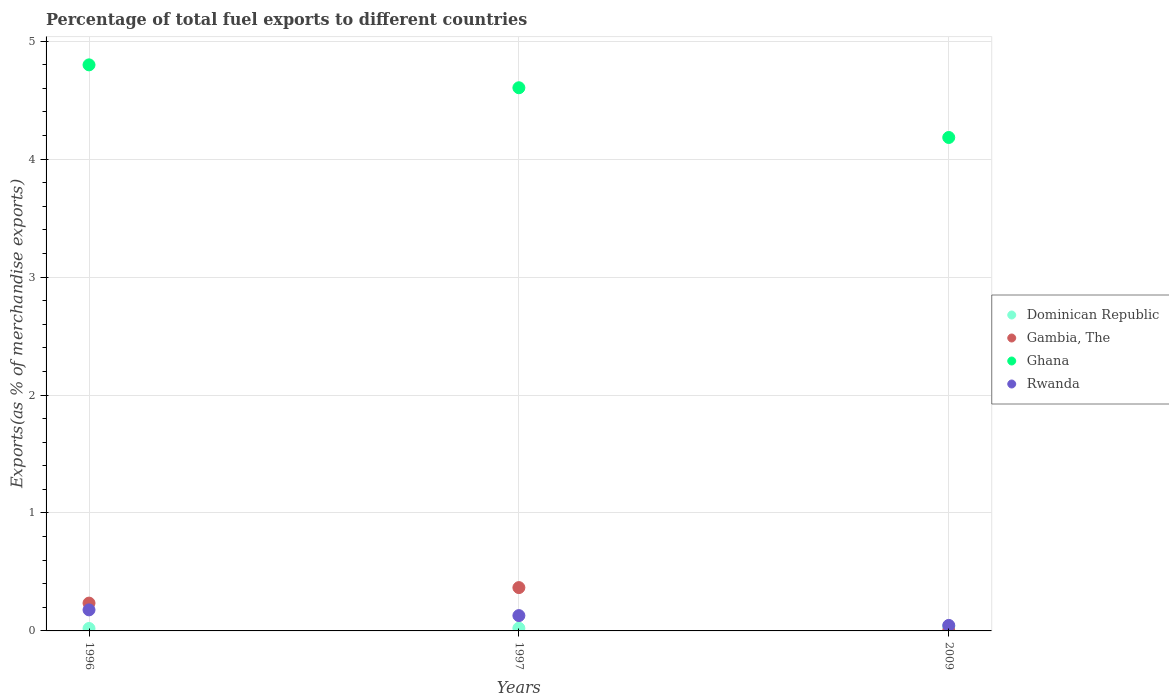How many different coloured dotlines are there?
Provide a short and direct response. 4. What is the percentage of exports to different countries in Gambia, The in 2009?
Your answer should be very brief. 0. Across all years, what is the maximum percentage of exports to different countries in Ghana?
Give a very brief answer. 4.8. Across all years, what is the minimum percentage of exports to different countries in Ghana?
Your answer should be very brief. 4.18. In which year was the percentage of exports to different countries in Ghana minimum?
Offer a terse response. 2009. What is the total percentage of exports to different countries in Dominican Republic in the graph?
Ensure brevity in your answer.  0.08. What is the difference between the percentage of exports to different countries in Ghana in 1997 and that in 2009?
Make the answer very short. 0.42. What is the difference between the percentage of exports to different countries in Rwanda in 1997 and the percentage of exports to different countries in Dominican Republic in 2009?
Your answer should be very brief. 0.09. What is the average percentage of exports to different countries in Rwanda per year?
Your response must be concise. 0.12. In the year 1997, what is the difference between the percentage of exports to different countries in Ghana and percentage of exports to different countries in Dominican Republic?
Your answer should be very brief. 4.58. What is the ratio of the percentage of exports to different countries in Ghana in 1996 to that in 2009?
Provide a succinct answer. 1.15. Is the difference between the percentage of exports to different countries in Ghana in 1997 and 2009 greater than the difference between the percentage of exports to different countries in Dominican Republic in 1997 and 2009?
Your answer should be compact. Yes. What is the difference between the highest and the second highest percentage of exports to different countries in Dominican Republic?
Provide a succinct answer. 0.02. What is the difference between the highest and the lowest percentage of exports to different countries in Ghana?
Your response must be concise. 0.62. Does the percentage of exports to different countries in Gambia, The monotonically increase over the years?
Provide a short and direct response. No. Is the percentage of exports to different countries in Gambia, The strictly less than the percentage of exports to different countries in Ghana over the years?
Ensure brevity in your answer.  Yes. How many years are there in the graph?
Offer a terse response. 3. Are the values on the major ticks of Y-axis written in scientific E-notation?
Your response must be concise. No. Does the graph contain grids?
Ensure brevity in your answer.  Yes. What is the title of the graph?
Provide a short and direct response. Percentage of total fuel exports to different countries. What is the label or title of the X-axis?
Keep it short and to the point. Years. What is the label or title of the Y-axis?
Your answer should be compact. Exports(as % of merchandise exports). What is the Exports(as % of merchandise exports) of Dominican Republic in 1996?
Your response must be concise. 0.02. What is the Exports(as % of merchandise exports) in Gambia, The in 1996?
Your answer should be very brief. 0.24. What is the Exports(as % of merchandise exports) in Ghana in 1996?
Provide a succinct answer. 4.8. What is the Exports(as % of merchandise exports) in Rwanda in 1996?
Keep it short and to the point. 0.18. What is the Exports(as % of merchandise exports) in Dominican Republic in 1997?
Ensure brevity in your answer.  0.02. What is the Exports(as % of merchandise exports) in Gambia, The in 1997?
Make the answer very short. 0.37. What is the Exports(as % of merchandise exports) of Ghana in 1997?
Offer a terse response. 4.6. What is the Exports(as % of merchandise exports) of Rwanda in 1997?
Ensure brevity in your answer.  0.13. What is the Exports(as % of merchandise exports) in Dominican Republic in 2009?
Offer a very short reply. 0.04. What is the Exports(as % of merchandise exports) of Gambia, The in 2009?
Make the answer very short. 0. What is the Exports(as % of merchandise exports) in Ghana in 2009?
Provide a succinct answer. 4.18. What is the Exports(as % of merchandise exports) of Rwanda in 2009?
Provide a short and direct response. 0.05. Across all years, what is the maximum Exports(as % of merchandise exports) in Dominican Republic?
Your answer should be compact. 0.04. Across all years, what is the maximum Exports(as % of merchandise exports) in Gambia, The?
Offer a terse response. 0.37. Across all years, what is the maximum Exports(as % of merchandise exports) of Ghana?
Keep it short and to the point. 4.8. Across all years, what is the maximum Exports(as % of merchandise exports) in Rwanda?
Your answer should be very brief. 0.18. Across all years, what is the minimum Exports(as % of merchandise exports) of Dominican Republic?
Offer a terse response. 0.02. Across all years, what is the minimum Exports(as % of merchandise exports) in Gambia, The?
Give a very brief answer. 0. Across all years, what is the minimum Exports(as % of merchandise exports) of Ghana?
Your answer should be very brief. 4.18. Across all years, what is the minimum Exports(as % of merchandise exports) of Rwanda?
Keep it short and to the point. 0.05. What is the total Exports(as % of merchandise exports) of Dominican Republic in the graph?
Give a very brief answer. 0.08. What is the total Exports(as % of merchandise exports) in Gambia, The in the graph?
Ensure brevity in your answer.  0.61. What is the total Exports(as % of merchandise exports) of Ghana in the graph?
Keep it short and to the point. 13.59. What is the total Exports(as % of merchandise exports) of Rwanda in the graph?
Ensure brevity in your answer.  0.35. What is the difference between the Exports(as % of merchandise exports) in Dominican Republic in 1996 and that in 1997?
Your answer should be compact. -0. What is the difference between the Exports(as % of merchandise exports) in Gambia, The in 1996 and that in 1997?
Provide a succinct answer. -0.13. What is the difference between the Exports(as % of merchandise exports) of Ghana in 1996 and that in 1997?
Make the answer very short. 0.19. What is the difference between the Exports(as % of merchandise exports) of Rwanda in 1996 and that in 1997?
Provide a succinct answer. 0.05. What is the difference between the Exports(as % of merchandise exports) of Dominican Republic in 1996 and that in 2009?
Provide a short and direct response. -0.02. What is the difference between the Exports(as % of merchandise exports) of Gambia, The in 1996 and that in 2009?
Your response must be concise. 0.23. What is the difference between the Exports(as % of merchandise exports) of Ghana in 1996 and that in 2009?
Your response must be concise. 0.62. What is the difference between the Exports(as % of merchandise exports) in Rwanda in 1996 and that in 2009?
Ensure brevity in your answer.  0.13. What is the difference between the Exports(as % of merchandise exports) in Dominican Republic in 1997 and that in 2009?
Keep it short and to the point. -0.02. What is the difference between the Exports(as % of merchandise exports) of Gambia, The in 1997 and that in 2009?
Your answer should be compact. 0.36. What is the difference between the Exports(as % of merchandise exports) in Ghana in 1997 and that in 2009?
Provide a succinct answer. 0.42. What is the difference between the Exports(as % of merchandise exports) in Rwanda in 1997 and that in 2009?
Ensure brevity in your answer.  0.08. What is the difference between the Exports(as % of merchandise exports) of Dominican Republic in 1996 and the Exports(as % of merchandise exports) of Gambia, The in 1997?
Your answer should be very brief. -0.35. What is the difference between the Exports(as % of merchandise exports) of Dominican Republic in 1996 and the Exports(as % of merchandise exports) of Ghana in 1997?
Your answer should be compact. -4.58. What is the difference between the Exports(as % of merchandise exports) of Dominican Republic in 1996 and the Exports(as % of merchandise exports) of Rwanda in 1997?
Your answer should be compact. -0.11. What is the difference between the Exports(as % of merchandise exports) of Gambia, The in 1996 and the Exports(as % of merchandise exports) of Ghana in 1997?
Your response must be concise. -4.37. What is the difference between the Exports(as % of merchandise exports) of Gambia, The in 1996 and the Exports(as % of merchandise exports) of Rwanda in 1997?
Ensure brevity in your answer.  0.11. What is the difference between the Exports(as % of merchandise exports) of Ghana in 1996 and the Exports(as % of merchandise exports) of Rwanda in 1997?
Keep it short and to the point. 4.67. What is the difference between the Exports(as % of merchandise exports) of Dominican Republic in 1996 and the Exports(as % of merchandise exports) of Gambia, The in 2009?
Offer a terse response. 0.02. What is the difference between the Exports(as % of merchandise exports) in Dominican Republic in 1996 and the Exports(as % of merchandise exports) in Ghana in 2009?
Offer a terse response. -4.16. What is the difference between the Exports(as % of merchandise exports) in Dominican Republic in 1996 and the Exports(as % of merchandise exports) in Rwanda in 2009?
Provide a short and direct response. -0.03. What is the difference between the Exports(as % of merchandise exports) of Gambia, The in 1996 and the Exports(as % of merchandise exports) of Ghana in 2009?
Offer a very short reply. -3.95. What is the difference between the Exports(as % of merchandise exports) of Gambia, The in 1996 and the Exports(as % of merchandise exports) of Rwanda in 2009?
Offer a terse response. 0.19. What is the difference between the Exports(as % of merchandise exports) of Ghana in 1996 and the Exports(as % of merchandise exports) of Rwanda in 2009?
Offer a very short reply. 4.75. What is the difference between the Exports(as % of merchandise exports) of Dominican Republic in 1997 and the Exports(as % of merchandise exports) of Gambia, The in 2009?
Provide a short and direct response. 0.02. What is the difference between the Exports(as % of merchandise exports) in Dominican Republic in 1997 and the Exports(as % of merchandise exports) in Ghana in 2009?
Ensure brevity in your answer.  -4.16. What is the difference between the Exports(as % of merchandise exports) of Dominican Republic in 1997 and the Exports(as % of merchandise exports) of Rwanda in 2009?
Make the answer very short. -0.02. What is the difference between the Exports(as % of merchandise exports) of Gambia, The in 1997 and the Exports(as % of merchandise exports) of Ghana in 2009?
Ensure brevity in your answer.  -3.82. What is the difference between the Exports(as % of merchandise exports) of Gambia, The in 1997 and the Exports(as % of merchandise exports) of Rwanda in 2009?
Keep it short and to the point. 0.32. What is the difference between the Exports(as % of merchandise exports) of Ghana in 1997 and the Exports(as % of merchandise exports) of Rwanda in 2009?
Provide a succinct answer. 4.56. What is the average Exports(as % of merchandise exports) in Dominican Republic per year?
Ensure brevity in your answer.  0.03. What is the average Exports(as % of merchandise exports) of Gambia, The per year?
Provide a short and direct response. 0.2. What is the average Exports(as % of merchandise exports) in Ghana per year?
Offer a very short reply. 4.53. What is the average Exports(as % of merchandise exports) of Rwanda per year?
Provide a succinct answer. 0.12. In the year 1996, what is the difference between the Exports(as % of merchandise exports) in Dominican Republic and Exports(as % of merchandise exports) in Gambia, The?
Offer a terse response. -0.22. In the year 1996, what is the difference between the Exports(as % of merchandise exports) of Dominican Republic and Exports(as % of merchandise exports) of Ghana?
Offer a terse response. -4.78. In the year 1996, what is the difference between the Exports(as % of merchandise exports) of Dominican Republic and Exports(as % of merchandise exports) of Rwanda?
Offer a very short reply. -0.16. In the year 1996, what is the difference between the Exports(as % of merchandise exports) in Gambia, The and Exports(as % of merchandise exports) in Ghana?
Keep it short and to the point. -4.56. In the year 1996, what is the difference between the Exports(as % of merchandise exports) of Gambia, The and Exports(as % of merchandise exports) of Rwanda?
Provide a succinct answer. 0.06. In the year 1996, what is the difference between the Exports(as % of merchandise exports) in Ghana and Exports(as % of merchandise exports) in Rwanda?
Your answer should be compact. 4.62. In the year 1997, what is the difference between the Exports(as % of merchandise exports) in Dominican Republic and Exports(as % of merchandise exports) in Gambia, The?
Make the answer very short. -0.34. In the year 1997, what is the difference between the Exports(as % of merchandise exports) in Dominican Republic and Exports(as % of merchandise exports) in Ghana?
Provide a succinct answer. -4.58. In the year 1997, what is the difference between the Exports(as % of merchandise exports) in Dominican Republic and Exports(as % of merchandise exports) in Rwanda?
Ensure brevity in your answer.  -0.11. In the year 1997, what is the difference between the Exports(as % of merchandise exports) of Gambia, The and Exports(as % of merchandise exports) of Ghana?
Ensure brevity in your answer.  -4.24. In the year 1997, what is the difference between the Exports(as % of merchandise exports) of Gambia, The and Exports(as % of merchandise exports) of Rwanda?
Your answer should be compact. 0.24. In the year 1997, what is the difference between the Exports(as % of merchandise exports) in Ghana and Exports(as % of merchandise exports) in Rwanda?
Your response must be concise. 4.47. In the year 2009, what is the difference between the Exports(as % of merchandise exports) in Dominican Republic and Exports(as % of merchandise exports) in Gambia, The?
Offer a terse response. 0.04. In the year 2009, what is the difference between the Exports(as % of merchandise exports) in Dominican Republic and Exports(as % of merchandise exports) in Ghana?
Ensure brevity in your answer.  -4.15. In the year 2009, what is the difference between the Exports(as % of merchandise exports) in Dominican Republic and Exports(as % of merchandise exports) in Rwanda?
Ensure brevity in your answer.  -0.01. In the year 2009, what is the difference between the Exports(as % of merchandise exports) in Gambia, The and Exports(as % of merchandise exports) in Ghana?
Keep it short and to the point. -4.18. In the year 2009, what is the difference between the Exports(as % of merchandise exports) in Gambia, The and Exports(as % of merchandise exports) in Rwanda?
Your answer should be very brief. -0.04. In the year 2009, what is the difference between the Exports(as % of merchandise exports) of Ghana and Exports(as % of merchandise exports) of Rwanda?
Make the answer very short. 4.14. What is the ratio of the Exports(as % of merchandise exports) in Dominican Republic in 1996 to that in 1997?
Ensure brevity in your answer.  0.9. What is the ratio of the Exports(as % of merchandise exports) in Gambia, The in 1996 to that in 1997?
Your answer should be very brief. 0.64. What is the ratio of the Exports(as % of merchandise exports) of Ghana in 1996 to that in 1997?
Provide a short and direct response. 1.04. What is the ratio of the Exports(as % of merchandise exports) in Rwanda in 1996 to that in 1997?
Offer a terse response. 1.37. What is the ratio of the Exports(as % of merchandise exports) of Dominican Republic in 1996 to that in 2009?
Keep it short and to the point. 0.54. What is the ratio of the Exports(as % of merchandise exports) of Gambia, The in 1996 to that in 2009?
Offer a terse response. 76.27. What is the ratio of the Exports(as % of merchandise exports) in Ghana in 1996 to that in 2009?
Provide a short and direct response. 1.15. What is the ratio of the Exports(as % of merchandise exports) in Rwanda in 1996 to that in 2009?
Make the answer very short. 3.82. What is the ratio of the Exports(as % of merchandise exports) of Dominican Republic in 1997 to that in 2009?
Ensure brevity in your answer.  0.6. What is the ratio of the Exports(as % of merchandise exports) of Gambia, The in 1997 to that in 2009?
Your response must be concise. 118.85. What is the ratio of the Exports(as % of merchandise exports) in Ghana in 1997 to that in 2009?
Make the answer very short. 1.1. What is the ratio of the Exports(as % of merchandise exports) of Rwanda in 1997 to that in 2009?
Provide a short and direct response. 2.78. What is the difference between the highest and the second highest Exports(as % of merchandise exports) of Dominican Republic?
Keep it short and to the point. 0.02. What is the difference between the highest and the second highest Exports(as % of merchandise exports) of Gambia, The?
Your answer should be very brief. 0.13. What is the difference between the highest and the second highest Exports(as % of merchandise exports) in Ghana?
Offer a very short reply. 0.19. What is the difference between the highest and the second highest Exports(as % of merchandise exports) of Rwanda?
Offer a terse response. 0.05. What is the difference between the highest and the lowest Exports(as % of merchandise exports) in Dominican Republic?
Ensure brevity in your answer.  0.02. What is the difference between the highest and the lowest Exports(as % of merchandise exports) in Gambia, The?
Your answer should be very brief. 0.36. What is the difference between the highest and the lowest Exports(as % of merchandise exports) of Ghana?
Your answer should be compact. 0.62. What is the difference between the highest and the lowest Exports(as % of merchandise exports) in Rwanda?
Offer a very short reply. 0.13. 